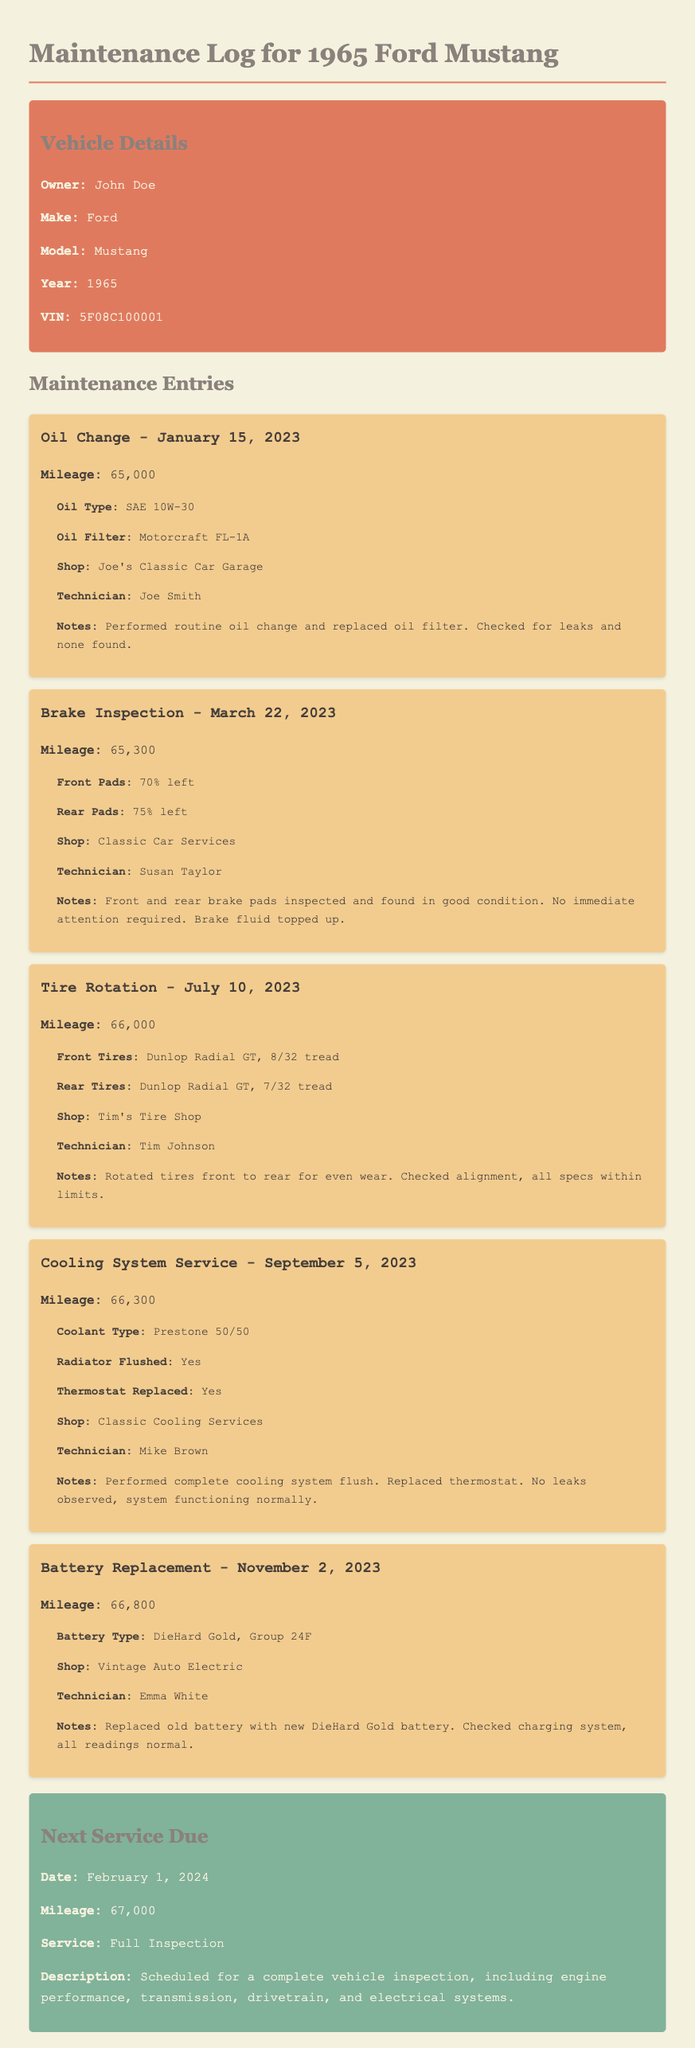What is the owner's name? The owner's name is explicitly mentioned in the vehicle details section of the document.
Answer: John Doe What is the mileage during the oil change? The document specifies the mileage at the time of each maintenance entry. For the oil change, it was 65,000.
Answer: 65,000 When was the brake inspection performed? The specific date of the brake inspection is noted in the maintenance entries.
Answer: March 22, 2023 What type of battery was replaced? The document lists the type of battery that was replaced in the last maintenance entry.
Answer: DieHard Gold, Group 24F What percentage of front brake pads was remaining? The maintenance entry for brake inspection provides the detailed status of the brake pads.
Answer: 70% Who performed the tire rotation? The technician's name for the tire rotation is mentioned in the relevant maintenance entry.
Answer: Tim Johnson What is the next service due date? The scheduled date for the next service is stated in the "Next Service Due" section.
Answer: February 1, 2024 What shop performed the cooling system service? The name of the shop that provided the cooling system service is included in the document.
Answer: Classic Cooling Services How many miles were on the vehicle during the battery replacement? The mileage during the battery replacement is noted in the corresponding maintenance entry.
Answer: 66,800 